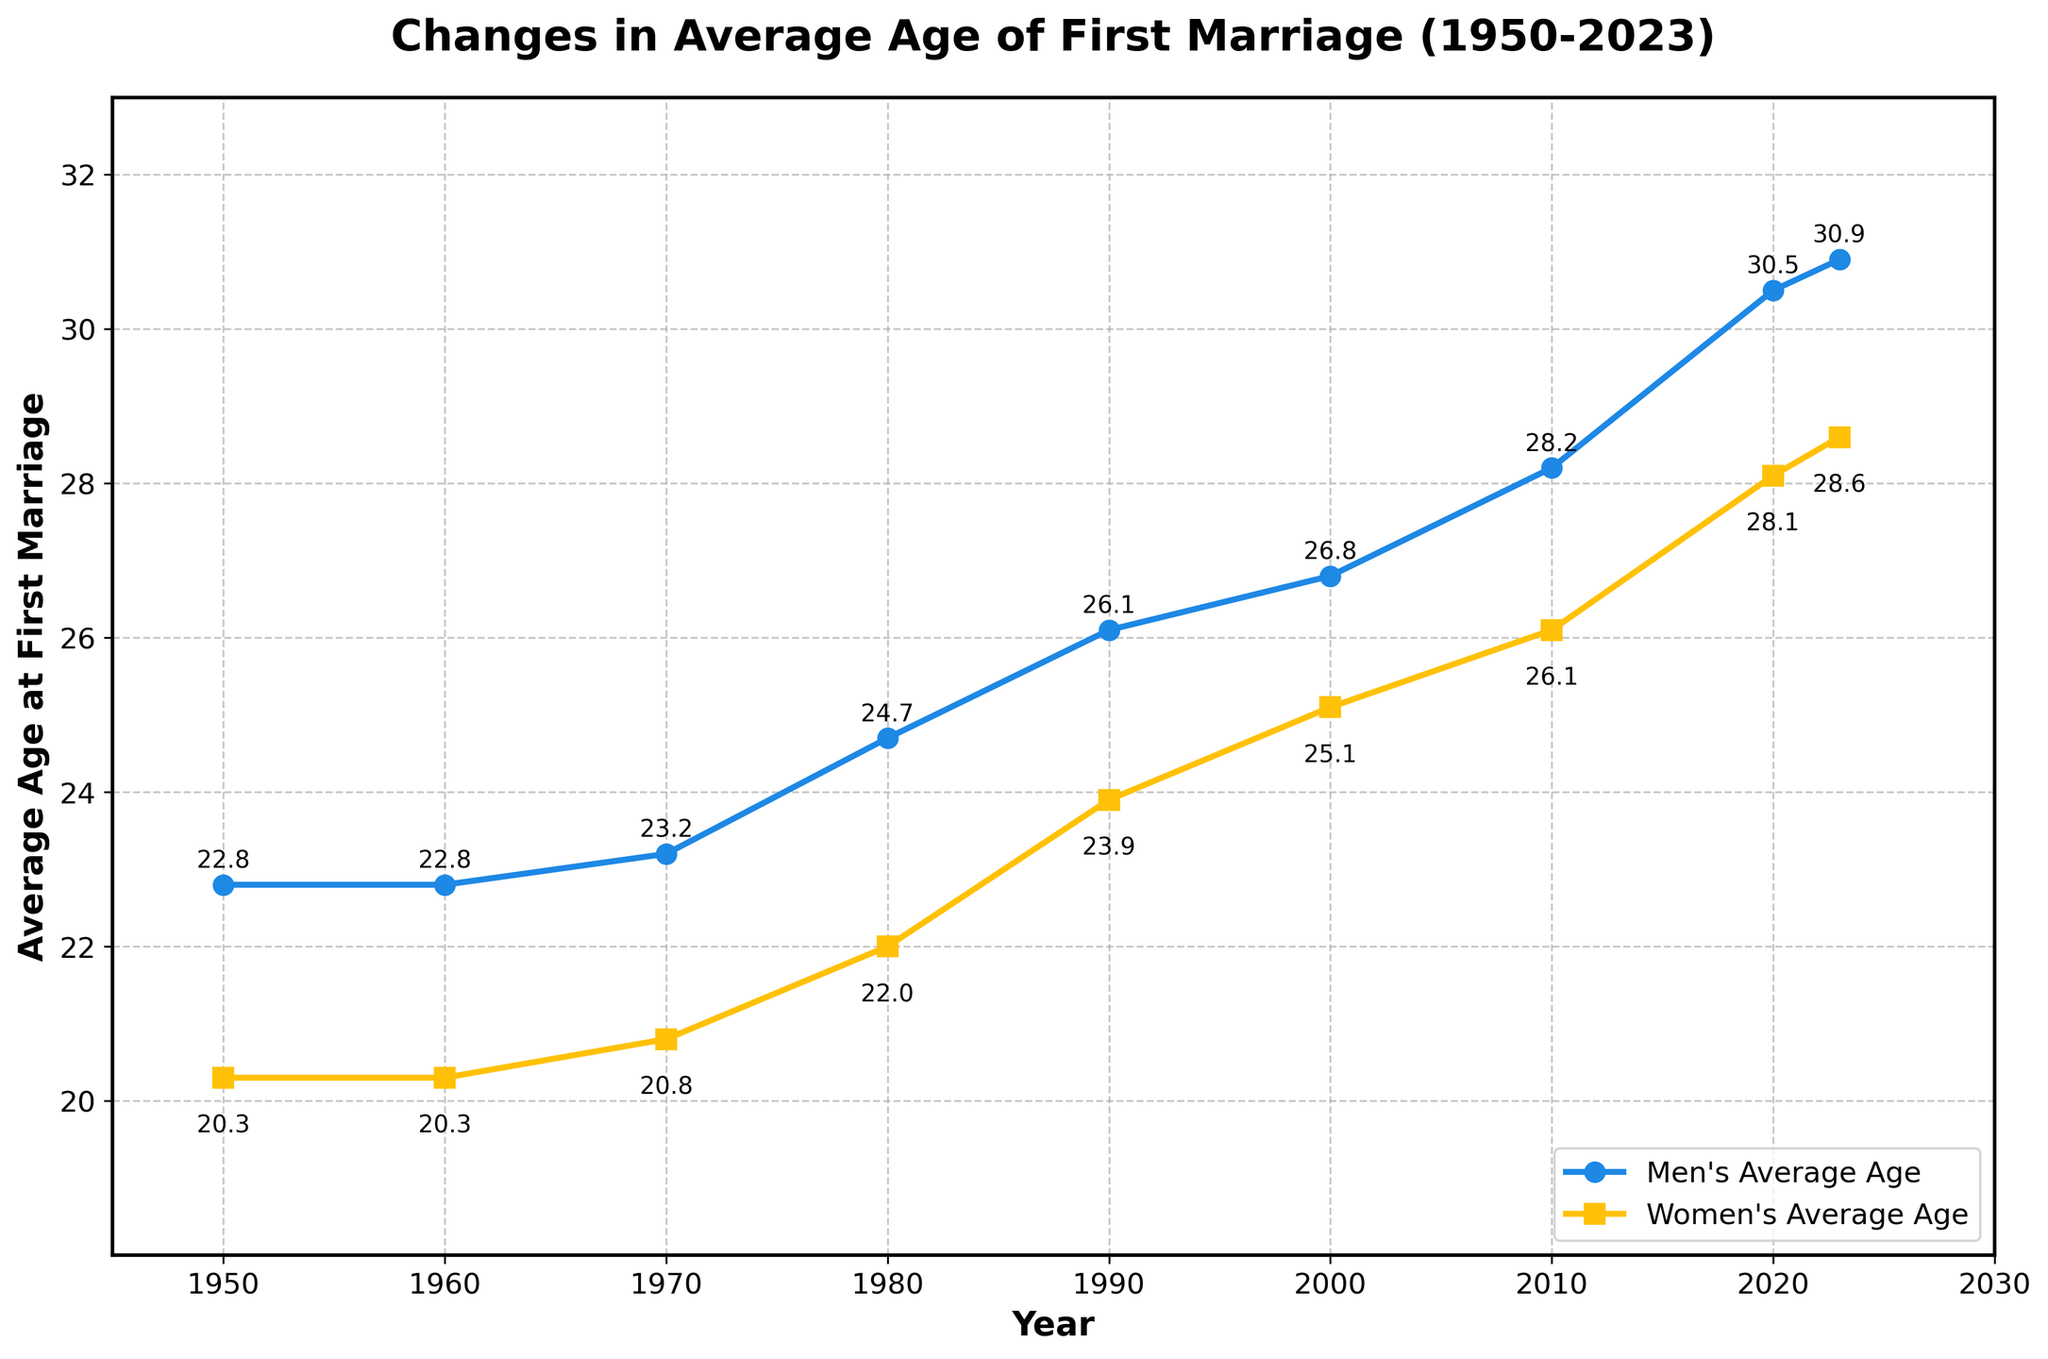What is the average age of first marriage for women in 1980? Look at the data point for the year 1980 and read the value on the y-axis for women.
Answer: 22.0 How much did the average age of first marriage for men increase from 1950 to 2023? Find the data points for men in 1950 and 2023. Subtract the 1950 value from the 2023 value: 30.9 - 22.8 = 8.1.
Answer: 8.1 In what year did women have an average age of first marriage equal to 25.1? Look for the data point where the women's age is 25.1 and read the corresponding year.
Answer: 2000 Which gender had a higher increase in the average age of first marriage from 1970 to 2023? Calculate the difference for men and women from 1970 to 2023: Men's increase: 30.9 - 23.2 = 7.7; Women's increase: 28.6 - 20.8 = 7.8. Compare the two increases, and women have the higher increase.
Answer: Women By how many years did the average age of first marriage for men increase from 1990 to 2010? Calculate the difference between the 2010 and 1990 data points for men: 28.2 - 26.1 = 2.1.
Answer: 2.1 What is the difference between the average ages of first marriages for men and women in 2020? Subtract the women's age from the men's age for the year 2020: 30.5 - 28.1 = 2.4.
Answer: 2.4 In which decade did the average age of first marriage for men surpass 25? Find the first year when the men's age is above 25. This occurs in 1990 when the age is 26.1. Therefore, it’s the 1990s.
Answer: 1990s What is the overall trend in the average age of first marriage for both men and women from 1950 to 2023? Observing the plot, both lines for men and women show a largely increasing trend from 1950 to 2023.
Answer: Increasing In which year is the difference between the average ages of first marriages for men and women the smallest, and what is the value? Find the year with the smallest gap: In 1960 and 1950, the gap is the smallest, equal to 2.5 years (22.8 - 20.3).
Answer: 1960 and 1950, 2.5 years 